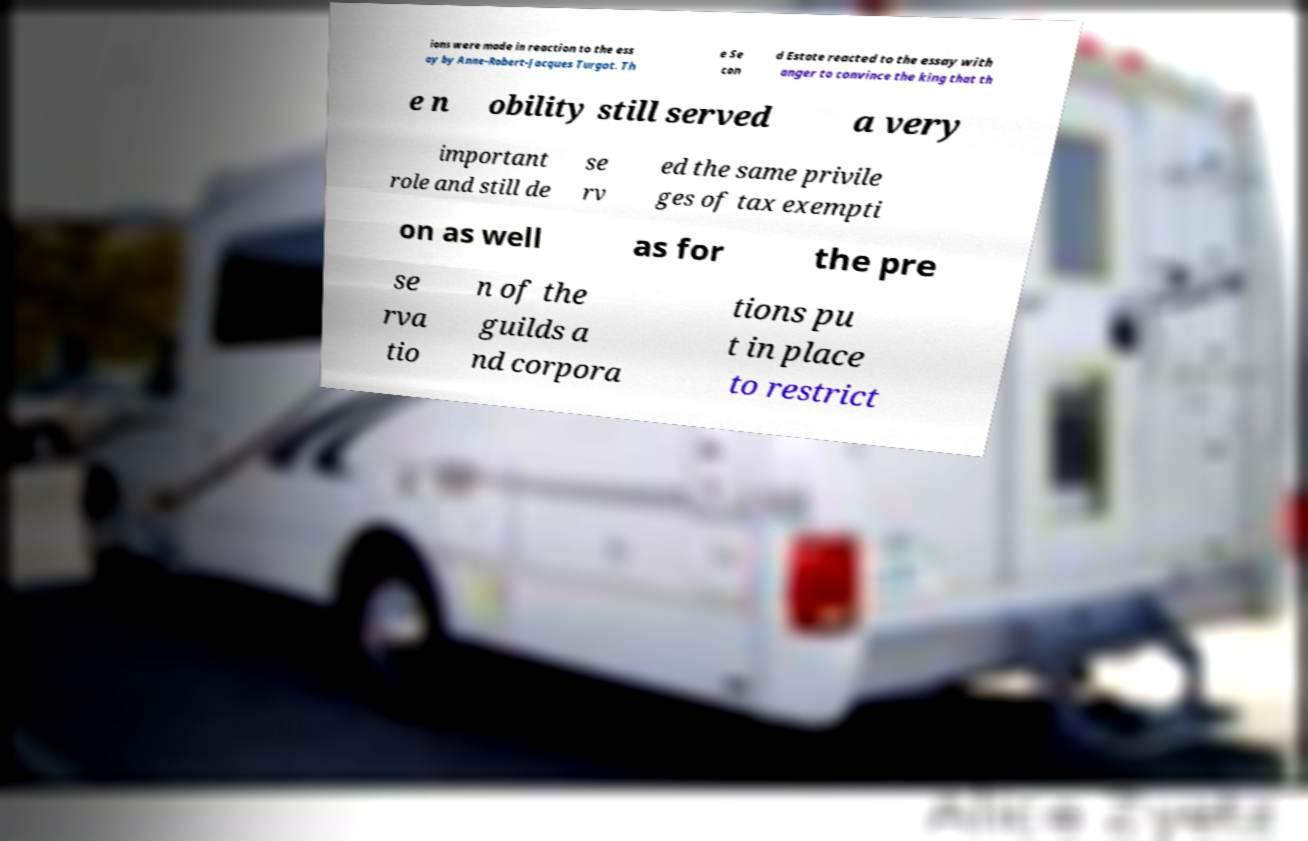What messages or text are displayed in this image? I need them in a readable, typed format. ions were made in reaction to the ess ay by Anne-Robert-Jacques Turgot. Th e Se con d Estate reacted to the essay with anger to convince the king that th e n obility still served a very important role and still de se rv ed the same privile ges of tax exempti on as well as for the pre se rva tio n of the guilds a nd corpora tions pu t in place to restrict 